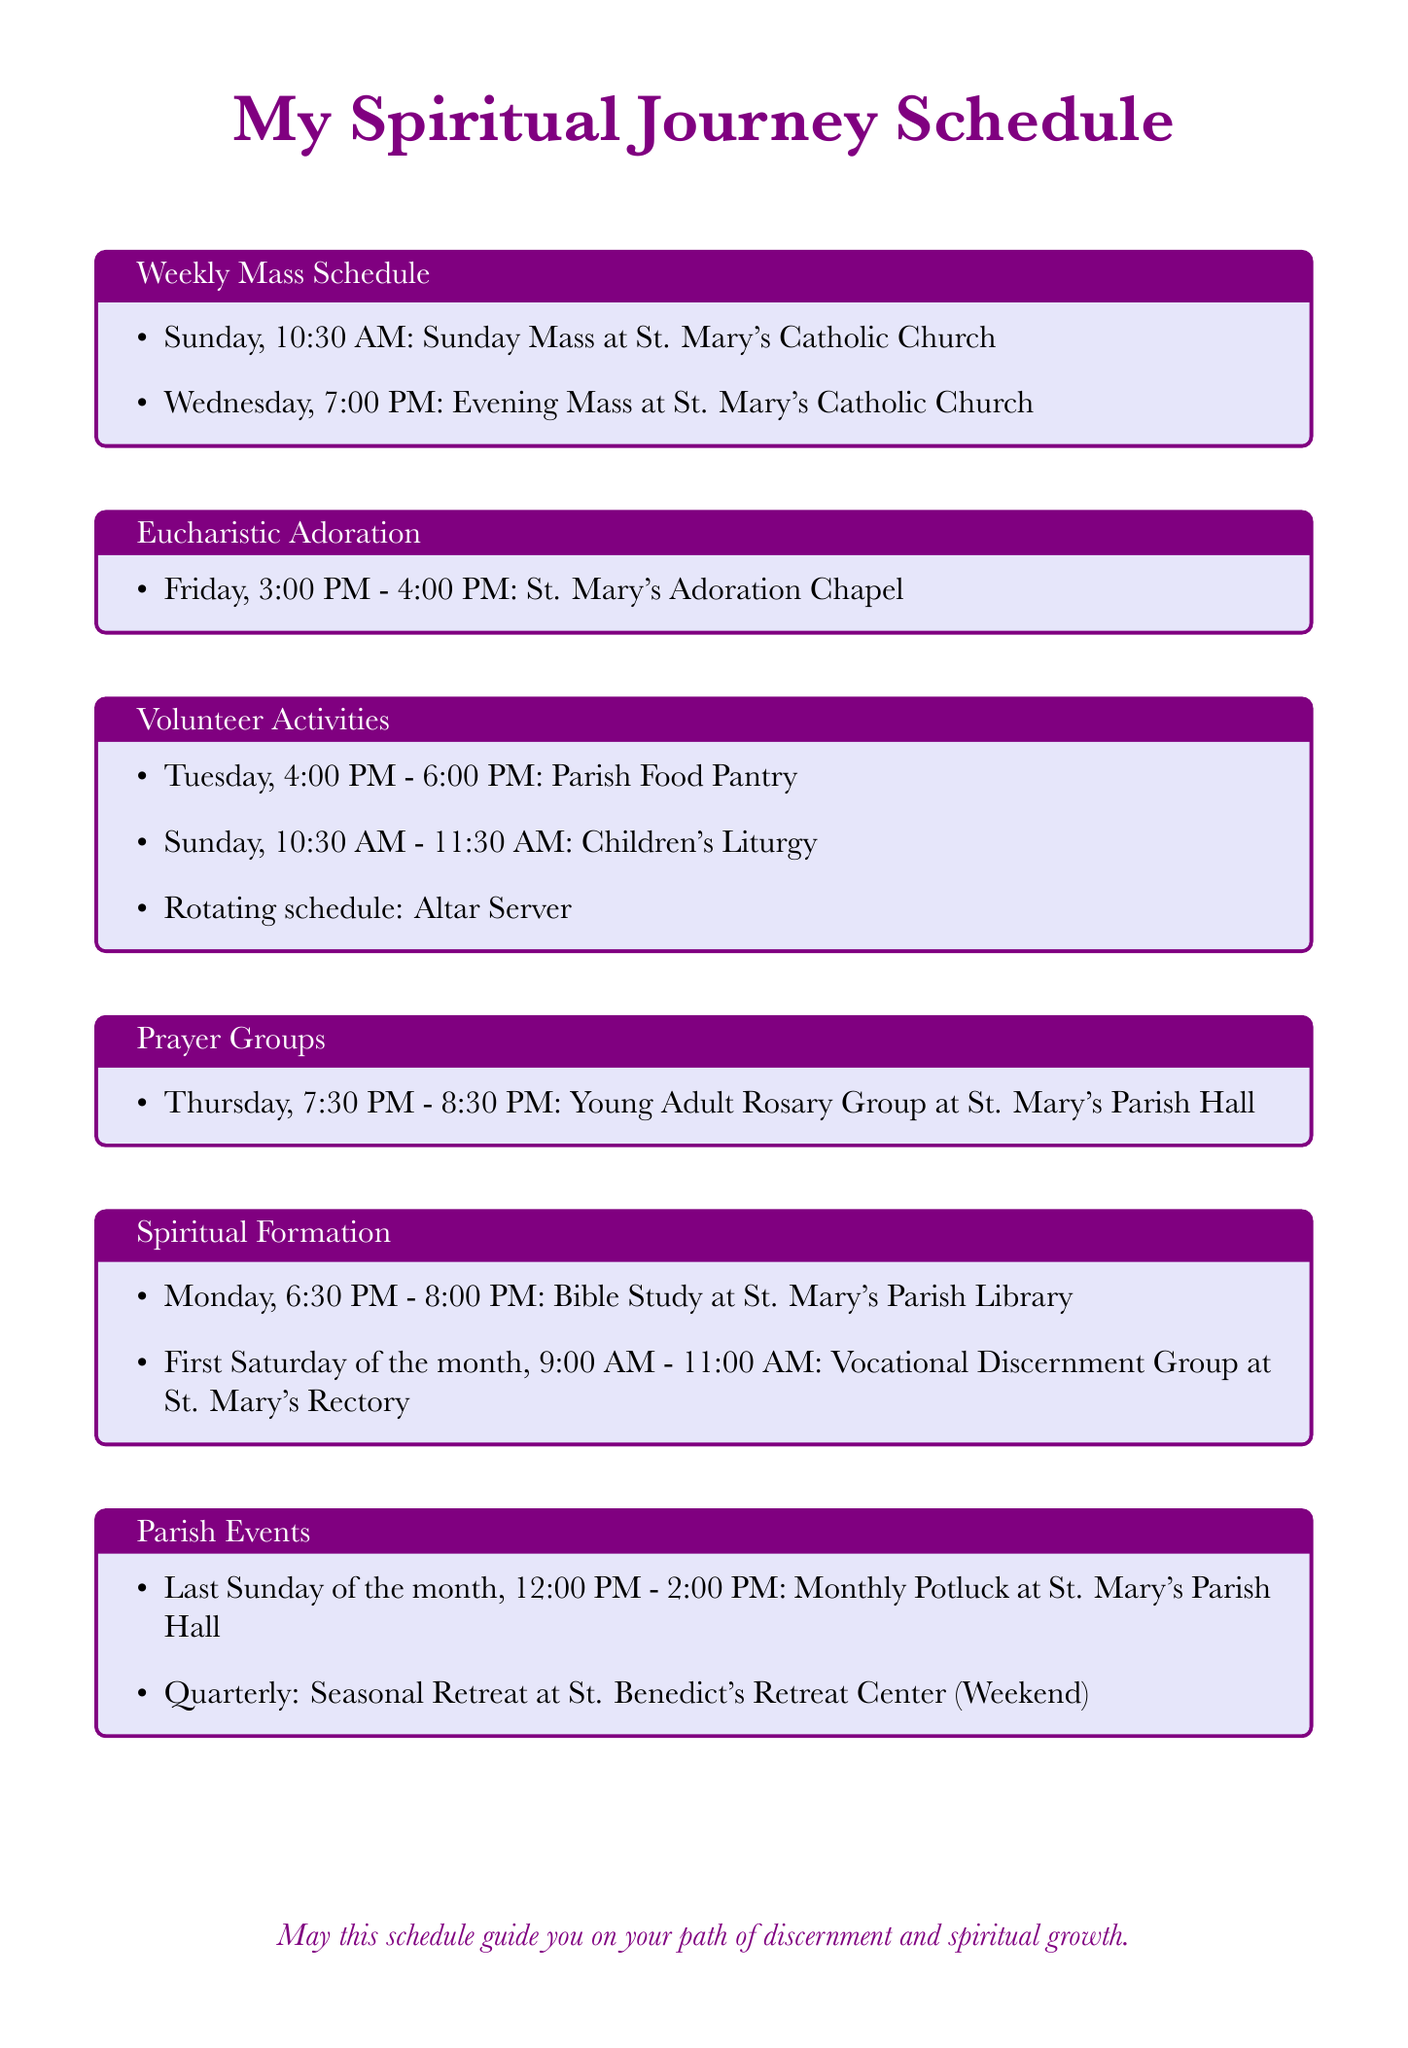What day and time is the Sunday Mass? The Sunday Mass is scheduled for Sunday at 10:30 AM as listed in the weekly mass schedule.
Answer: Sunday, 10:30 AM When does Eucharistic Adoration take place? Eucharistic Adoration is held on Friday from 3:00 PM to 4:00 PM as specified in the document.
Answer: Friday, 3:00 PM - 4:00 PM What activity is scheduled on Tuesday from 4:00 PM to 6:00 PM? The document states that the Parish Food Pantry operates during this time on Tuesday.
Answer: Parish Food Pantry On which day is the Vocational Discernment Group held? The Vocational Discernment Group meets on the first Saturday of the month according to the spiritual formation section.
Answer: First Saturday of the month How often is the Seasonal Retreat held? The document indicates that the Seasonal Retreat occurs quarterly, which implies it takes place four times a year.
Answer: Quarterly 